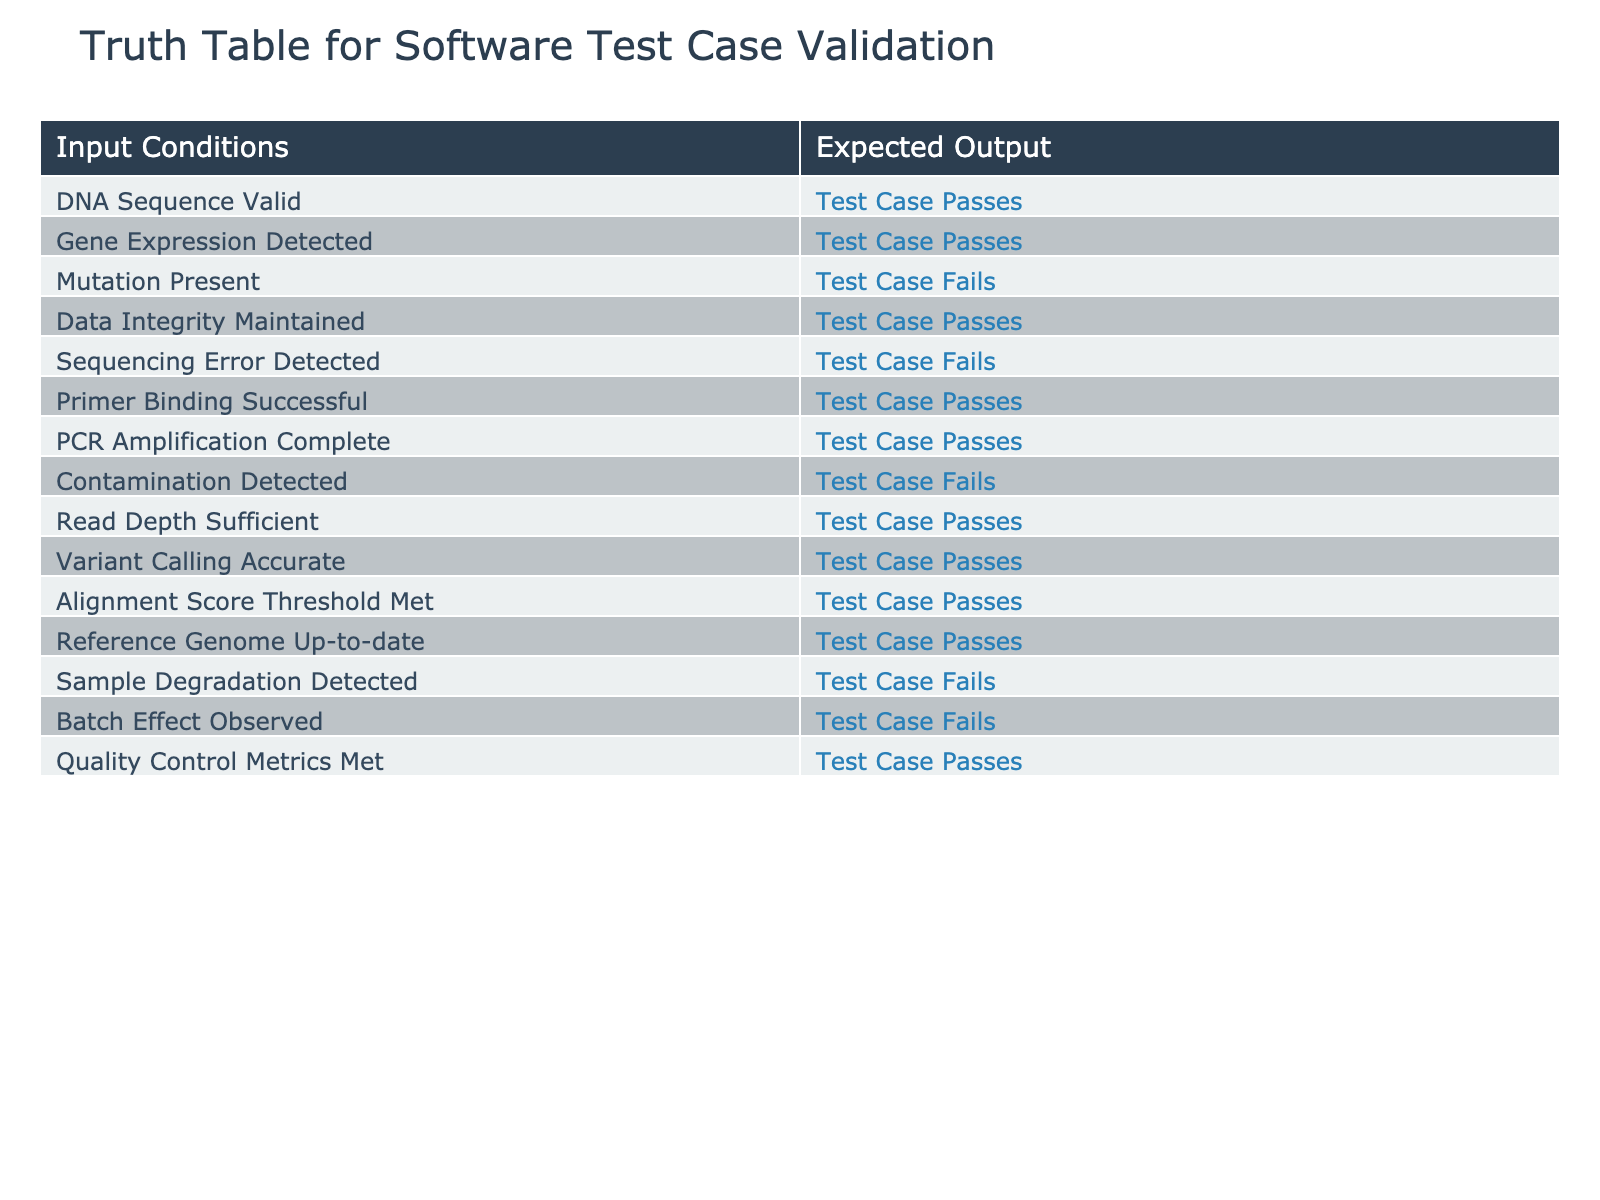What is the expected output when "DNA Sequence Valid" is true? According to the table, if "DNA Sequence Valid" is true, then the corresponding expected output is "Test Case Passes".
Answer: Test Case Passes Is "Contamination Detected" associated with a passing test case? The table shows that when "Contamination Detected" is true, the expected output is "Test Case Fails". Therefore, it is not associated with a passing test case.
Answer: No How many conditions lead to a "Test Case Fails"? By counting the rows in the table, we find that out of the conditions listed, four lead to "Test Case Fails" (Mutation Present, Sequencing Error Detected, Contamination Detected, Sample Degradation Detected, and Batch Effect Observed).
Answer: 5 What is the expected output if both "Gene Expression Detected" and "Quality Control Metrics Met" are true? Given that both conditions are true, we check their individual expected outputs. "Gene Expression Detected" results in "Test Case Passes" and "Quality Control Metrics Met" also results in "Test Case Passes". Since both conditions yield a pass, the overall expected output remains "Test Case Passes".
Answer: Test Case Passes Are there more positive outputs than negative outputs in the expected outcomes? The table indicates that there are a total of 15 conditions; 10 of them lead to "Test Case Passes" and 5 lead to "Test Case Fails". Therefore, there are more positive outputs than negative outputs.
Answer: Yes If "Primer Binding Successful" is false, what can be inferred about the test case outcome? We observe that the table does not state directly about the scenario for when "Primer Binding Successful" is false. We must conclude that we cannot determine the outcome without additional conditions being considered. In this case, nothing specific about the outcome can be inferred.
Answer: Indeterminate What is the relationship between "Read Depth Sufficient" and "Variant Calling Accurate" in terms of expected output? The table indicates that both "Read Depth Sufficient" and "Variant Calling Accurate" result in "Test Case Passes." This shows that both conditions are independent and contribute positively to the test case outcome.
Answer: Both pass the test case Count how many conditions are associated with a "Test Case Passes" result? To find this, we examine the conditions listed and count those that lead to "Test Case Passes". There are 10 such conditions indicated in the table.
Answer: 10 What must be true for the overall test case to pass? The test case passes if all conditions that yield a passing result are satisfied, i.e., none of the conditions for failure must be true at the same time. Specifically, if the conditions yielding "Test Case Fails" are not met while the leaning "Passes" conditions are true, then overall it can be concluded that the test case passes.
Answer: All pass conditions true; no fail conditions true 